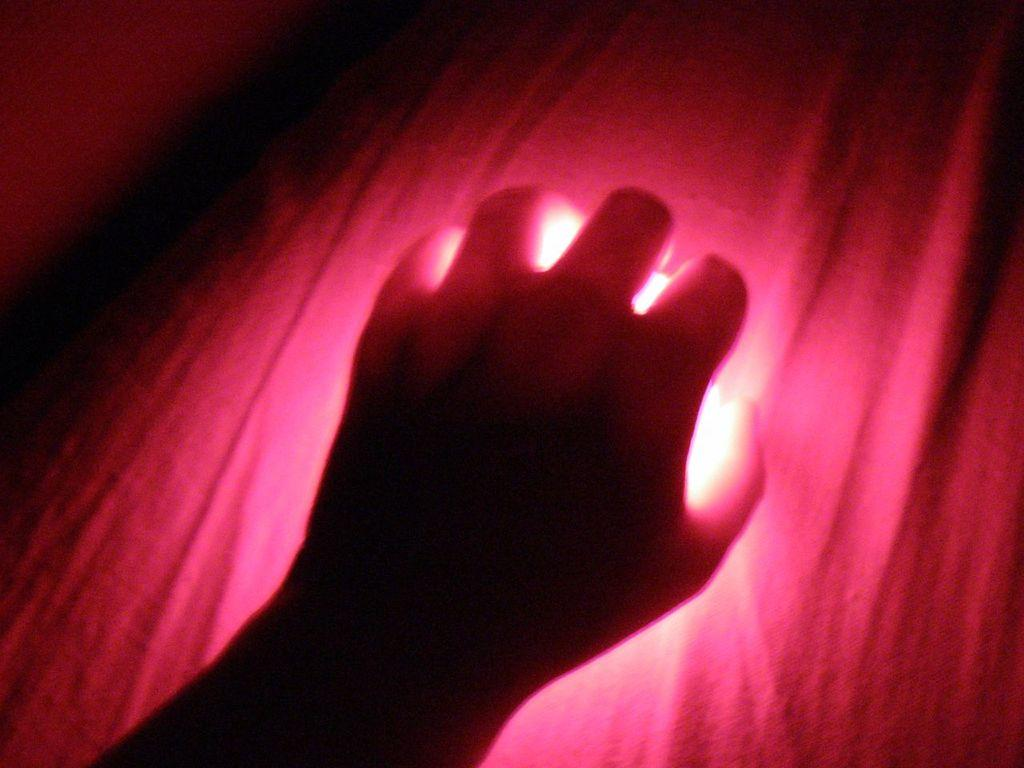What is the main subject of the image? The main subject of the image is a person's hand. What can be seen in the background of the image? The background of the image is pink. Can you tell me how many bees are buzzing around the person's throat in the image? There are no bees or any reference to a throat in the image; it only features a person's hand and a pink background. 